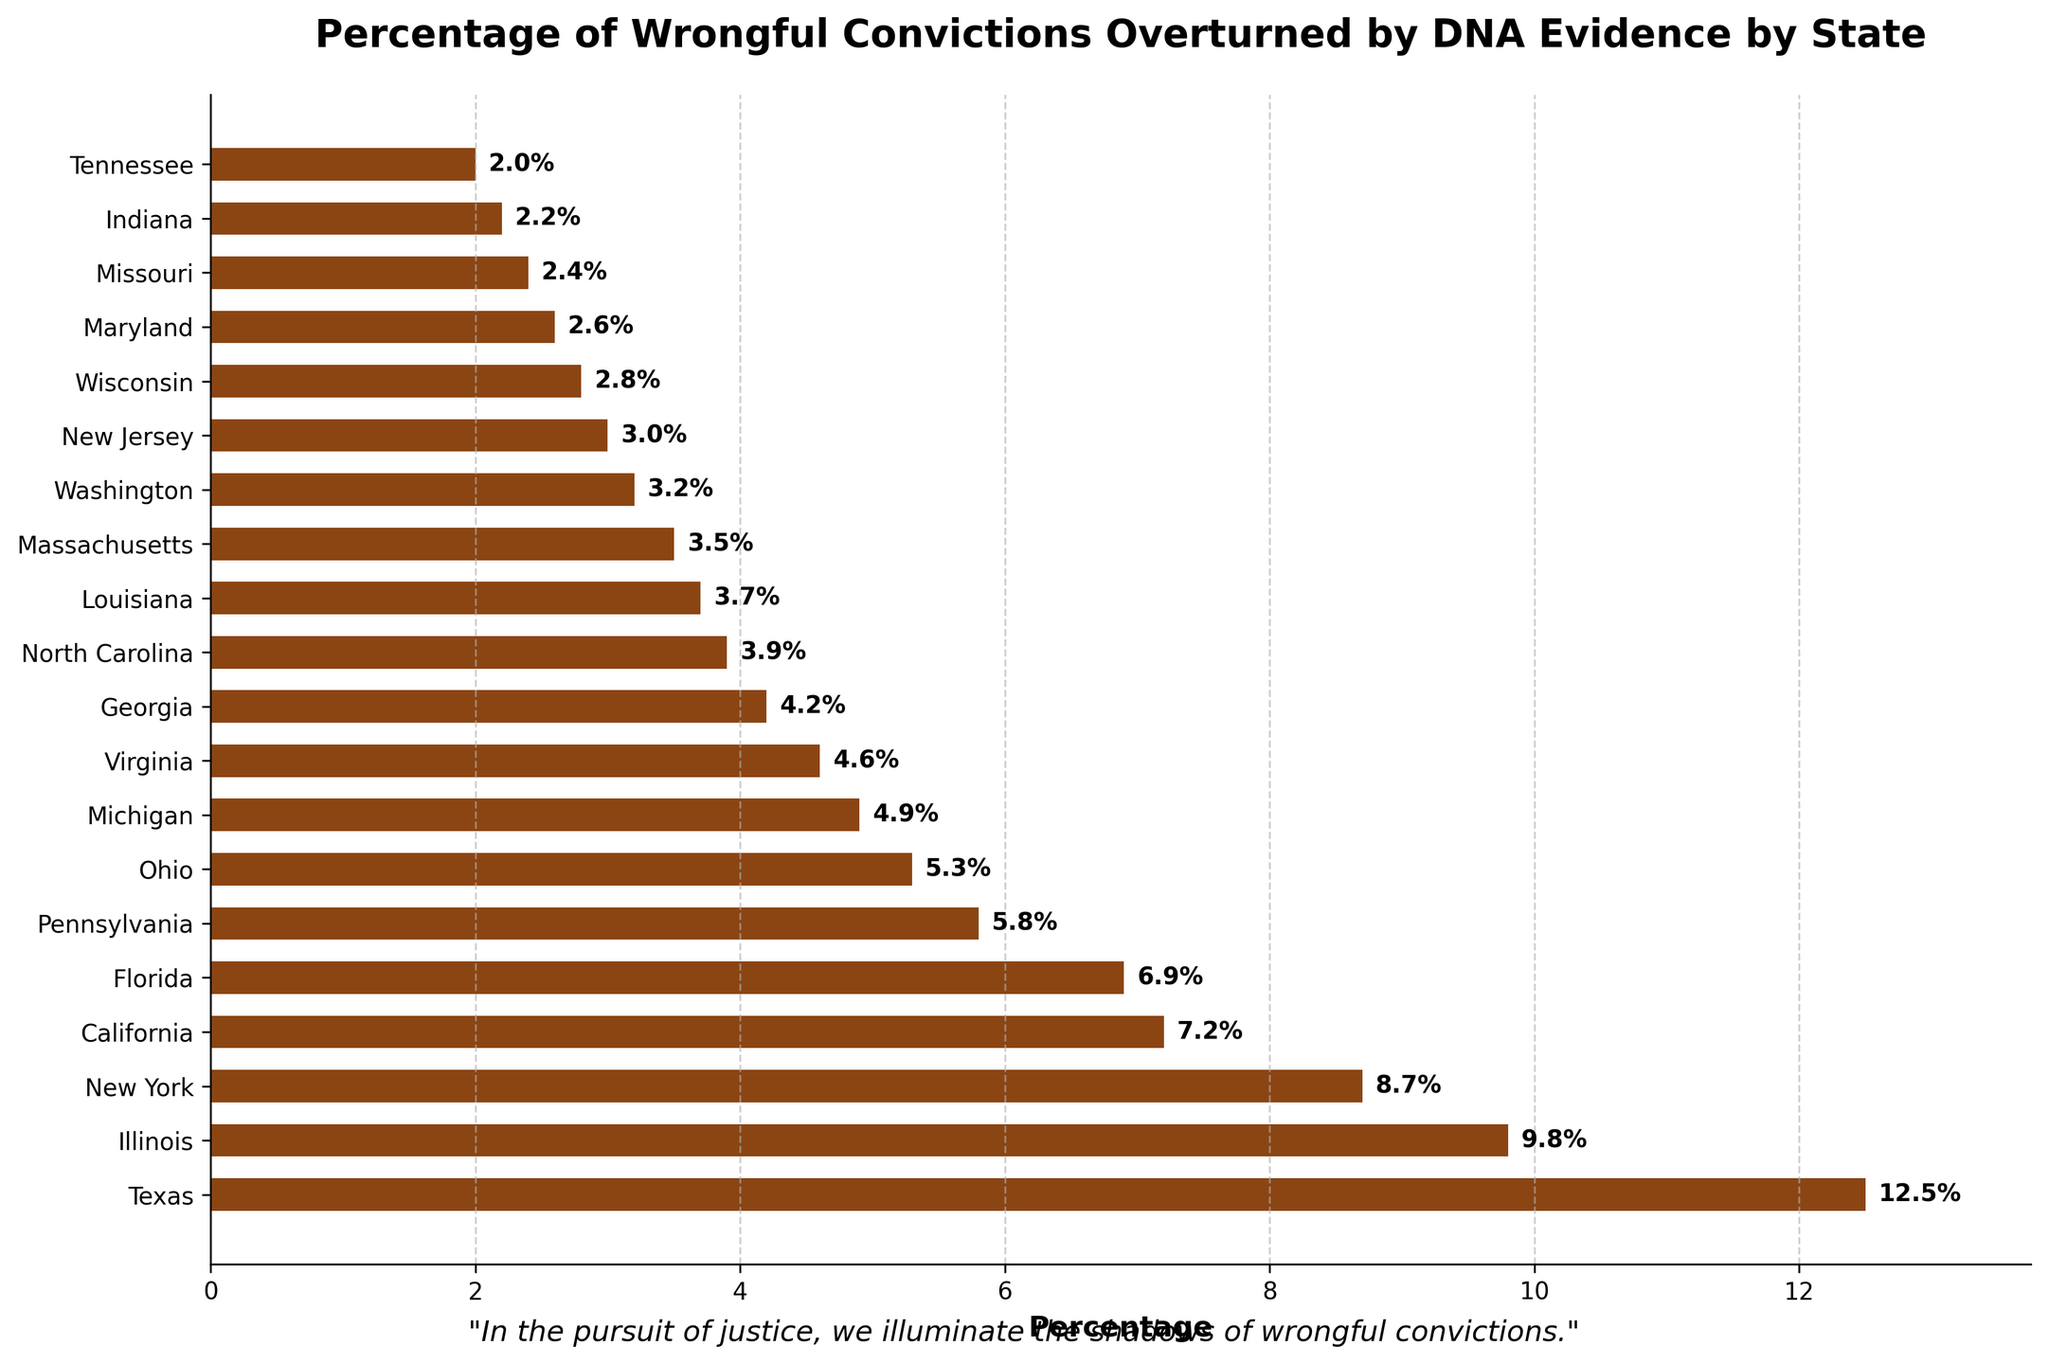Which state has the highest percentage of wrongful convictions overturned by DNA evidence? The state with the highest bar length represents the highest percentage. In this figure, Texas has the longest bar.
Answer: Texas Which states have a percentage of wrongful convictions overturned by DNA evidence lower than 5%? Identify bars shorter than the 5% mark. These states include Wisconsin, Maryland, Missouri, Indiana, and Tennessee.
Answer: Wisconsin, Maryland, Missouri, Indiana, Tennessee How many states have a percentage of wrongful convictions overturned by DNA evidence above 6%? Count the bars that are longer than 6%. There are five such states: Texas, Illinois, New York, California, and Florida.
Answer: 5 What is the percentage difference between Texas and Illinois? Subtract Illinois's percentage (9.8%) from Texas's percentage (12.5%). 12.5% - 9.8% = 2.7%.
Answer: 2.7% Which state has the same percentage of wrongful convictions overturned by DNA evidence as New Jersey, but logically compared, has a higher percentage than Wisconsin? New Jersey has 3.0%. Compare each state's bar; Massachusetts has 3.5%, higher than Wisconsin's 2.8%.
Answer: Massachusetts Are there more states with percentages of wrongful convictions overturned by DNA evidence above or below 5%? Count states above 5% and states below 5% and compare totals. There are 7 states above and 13 states below 5%.
Answer: Below What is the average percentage of wrongful convictions overturned by DNA evidence in the top five states? Sum the percentages for Texas, Illinois, New York, California, and Florida: 12.5 + 9.8 + 8.7 + 7.2 + 6.9 = 45.1. Divide by the number of states (5). 45.1 / 5 = 9.02%.
Answer: 9.02% Which state has the shortest bar in the chart, and what is its percentage? Identify the shortest bar visually, which belongs to Tennessee, with a percentage of 2.0%.
Answer: Tennessee, 2.0% Compare the total percentage sum of wrongful convictions overturned by DNA evidence for Pennsylvania, Ohio, and Michigan versus Massachusetts, Washington, and New Jersey. Which group has a higher sum? Sum for Pennsylvania, Ohio, Michigan: 5.8 + 5.3 + 4.9 = 16.0%. Sum for Massachusetts, Washington, New Jersey: 3.5 + 3.2 + 3.0 = 9.7%. 16.0% is higher than 9.7%.
Answer: Penn., Ohio, Mich What visual characteristic emphasizes the importance of wrongful convictions being overturned, as noted at the bottom of the chart? A quote, "In the pursuit of justice, we illuminate the shadows of wrongful convictions," is displayed at the bottom to provide a poetic touch and highlight the gravity of the issue.
Answer: Poetic quote 